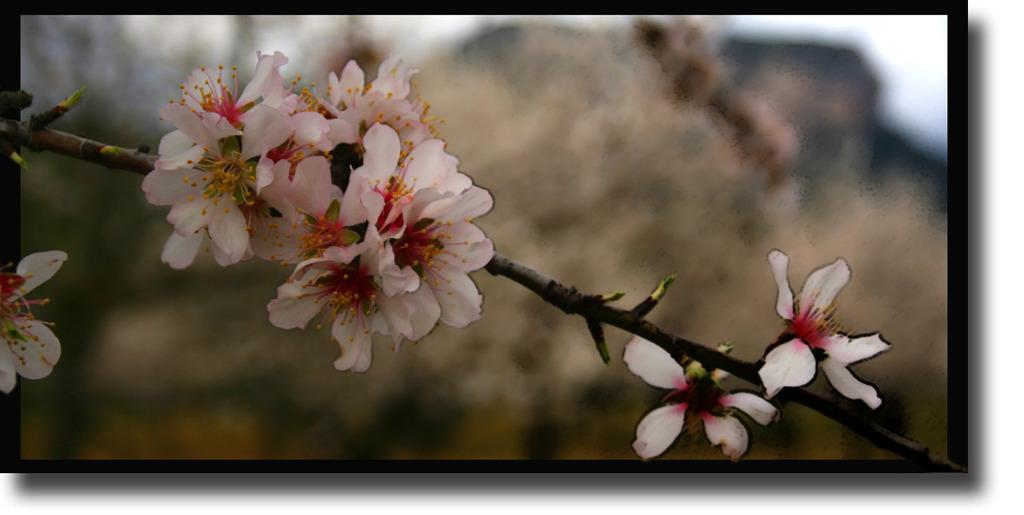What type of flowers are present in the image? There are white color flowers in the image. How many waves can be seen crashing on the shore in the image? There are no waves present in the image; it features white color flowers. What type of seed is used to grow the flowers in the image? The provided facts do not mention any information about the type of seed used to grow the flowers, so it cannot be determined from the image. 